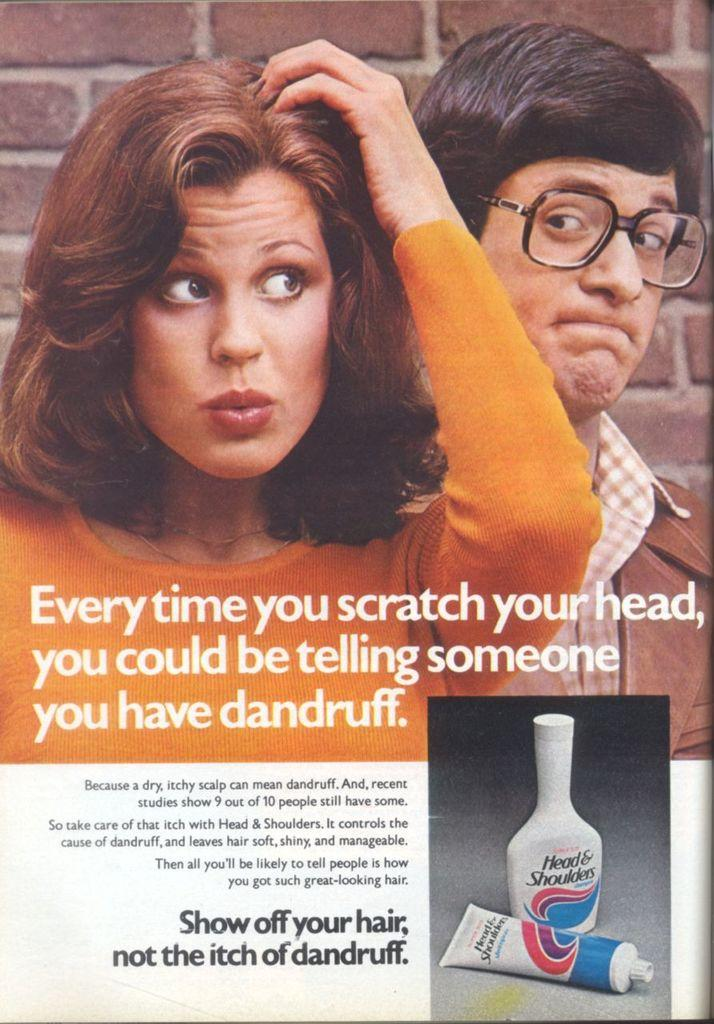<image>
Describe the image concisely. An advertisement for an anti dandruff shampoo from Head & Shoulders 